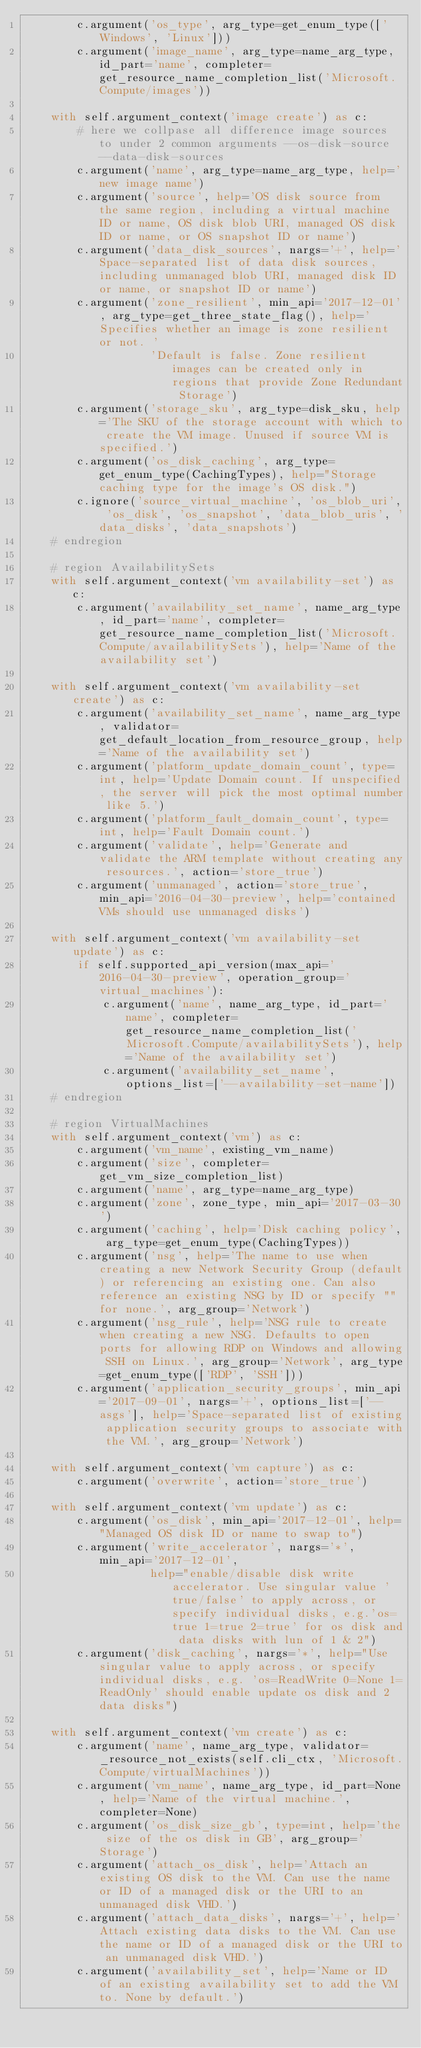<code> <loc_0><loc_0><loc_500><loc_500><_Python_>        c.argument('os_type', arg_type=get_enum_type(['Windows', 'Linux']))
        c.argument('image_name', arg_type=name_arg_type, id_part='name', completer=get_resource_name_completion_list('Microsoft.Compute/images'))

    with self.argument_context('image create') as c:
        # here we collpase all difference image sources to under 2 common arguments --os-disk-source --data-disk-sources
        c.argument('name', arg_type=name_arg_type, help='new image name')
        c.argument('source', help='OS disk source from the same region, including a virtual machine ID or name, OS disk blob URI, managed OS disk ID or name, or OS snapshot ID or name')
        c.argument('data_disk_sources', nargs='+', help='Space-separated list of data disk sources, including unmanaged blob URI, managed disk ID or name, or snapshot ID or name')
        c.argument('zone_resilient', min_api='2017-12-01', arg_type=get_three_state_flag(), help='Specifies whether an image is zone resilient or not. '
                   'Default is false. Zone resilient images can be created only in regions that provide Zone Redundant Storage')
        c.argument('storage_sku', arg_type=disk_sku, help='The SKU of the storage account with which to create the VM image. Unused if source VM is specified.')
        c.argument('os_disk_caching', arg_type=get_enum_type(CachingTypes), help="Storage caching type for the image's OS disk.")
        c.ignore('source_virtual_machine', 'os_blob_uri', 'os_disk', 'os_snapshot', 'data_blob_uris', 'data_disks', 'data_snapshots')
    # endregion

    # region AvailabilitySets
    with self.argument_context('vm availability-set') as c:
        c.argument('availability_set_name', name_arg_type, id_part='name', completer=get_resource_name_completion_list('Microsoft.Compute/availabilitySets'), help='Name of the availability set')

    with self.argument_context('vm availability-set create') as c:
        c.argument('availability_set_name', name_arg_type, validator=get_default_location_from_resource_group, help='Name of the availability set')
        c.argument('platform_update_domain_count', type=int, help='Update Domain count. If unspecified, the server will pick the most optimal number like 5.')
        c.argument('platform_fault_domain_count', type=int, help='Fault Domain count.')
        c.argument('validate', help='Generate and validate the ARM template without creating any resources.', action='store_true')
        c.argument('unmanaged', action='store_true', min_api='2016-04-30-preview', help='contained VMs should use unmanaged disks')

    with self.argument_context('vm availability-set update') as c:
        if self.supported_api_version(max_api='2016-04-30-preview', operation_group='virtual_machines'):
            c.argument('name', name_arg_type, id_part='name', completer=get_resource_name_completion_list('Microsoft.Compute/availabilitySets'), help='Name of the availability set')
            c.argument('availability_set_name', options_list=['--availability-set-name'])
    # endregion

    # region VirtualMachines
    with self.argument_context('vm') as c:
        c.argument('vm_name', existing_vm_name)
        c.argument('size', completer=get_vm_size_completion_list)
        c.argument('name', arg_type=name_arg_type)
        c.argument('zone', zone_type, min_api='2017-03-30')
        c.argument('caching', help='Disk caching policy', arg_type=get_enum_type(CachingTypes))
        c.argument('nsg', help='The name to use when creating a new Network Security Group (default) or referencing an existing one. Can also reference an existing NSG by ID or specify "" for none.', arg_group='Network')
        c.argument('nsg_rule', help='NSG rule to create when creating a new NSG. Defaults to open ports for allowing RDP on Windows and allowing SSH on Linux.', arg_group='Network', arg_type=get_enum_type(['RDP', 'SSH']))
        c.argument('application_security_groups', min_api='2017-09-01', nargs='+', options_list=['--asgs'], help='Space-separated list of existing application security groups to associate with the VM.', arg_group='Network')

    with self.argument_context('vm capture') as c:
        c.argument('overwrite', action='store_true')

    with self.argument_context('vm update') as c:
        c.argument('os_disk', min_api='2017-12-01', help="Managed OS disk ID or name to swap to")
        c.argument('write_accelerator', nargs='*', min_api='2017-12-01',
                   help="enable/disable disk write accelerator. Use singular value 'true/false' to apply across, or specify individual disks, e.g.'os=true 1=true 2=true' for os disk and data disks with lun of 1 & 2")
        c.argument('disk_caching', nargs='*', help="Use singular value to apply across, or specify individual disks, e.g. 'os=ReadWrite 0=None 1=ReadOnly' should enable update os disk and 2 data disks")

    with self.argument_context('vm create') as c:
        c.argument('name', name_arg_type, validator=_resource_not_exists(self.cli_ctx, 'Microsoft.Compute/virtualMachines'))
        c.argument('vm_name', name_arg_type, id_part=None, help='Name of the virtual machine.', completer=None)
        c.argument('os_disk_size_gb', type=int, help='the size of the os disk in GB', arg_group='Storage')
        c.argument('attach_os_disk', help='Attach an existing OS disk to the VM. Can use the name or ID of a managed disk or the URI to an unmanaged disk VHD.')
        c.argument('attach_data_disks', nargs='+', help='Attach existing data disks to the VM. Can use the name or ID of a managed disk or the URI to an unmanaged disk VHD.')
        c.argument('availability_set', help='Name or ID of an existing availability set to add the VM to. None by default.')</code> 